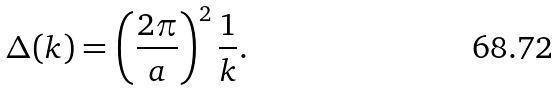<formula> <loc_0><loc_0><loc_500><loc_500>\Delta ( k ) = \left ( \frac { 2 \pi } { a } \right ) ^ { 2 } \frac { 1 } { k } .</formula> 